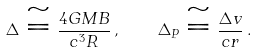<formula> <loc_0><loc_0><loc_500><loc_500>\Delta \cong \frac { 4 G M B } { c ^ { 3 } R } \, , \quad \Delta _ { P } \cong \frac { \Delta v } { c r } \, .</formula> 